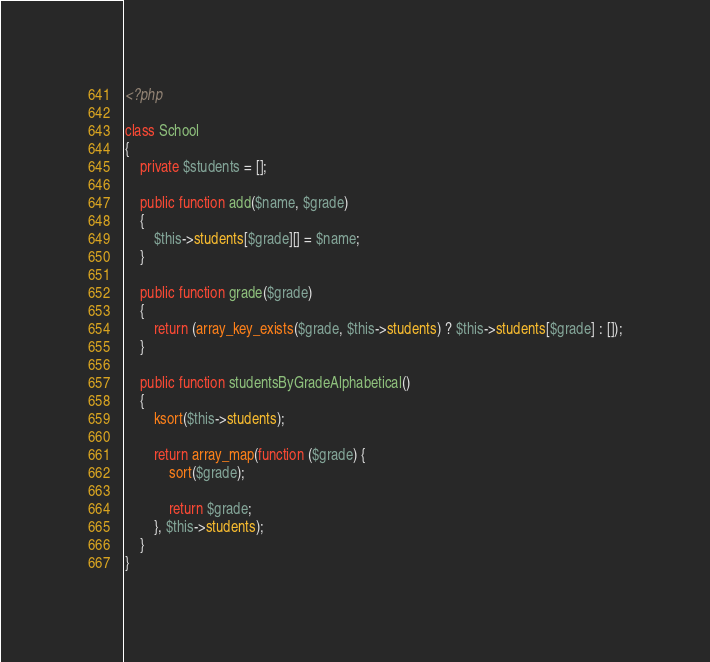Convert code to text. <code><loc_0><loc_0><loc_500><loc_500><_PHP_><?php

class School
{
    private $students = [];

    public function add($name, $grade)
    {
        $this->students[$grade][] = $name;
    }

    public function grade($grade)
    {
        return (array_key_exists($grade, $this->students) ? $this->students[$grade] : []);
    }

    public function studentsByGradeAlphabetical()
    {
        ksort($this->students);

        return array_map(function ($grade) {
            sort($grade);

            return $grade;
        }, $this->students);
    }
}
</code> 